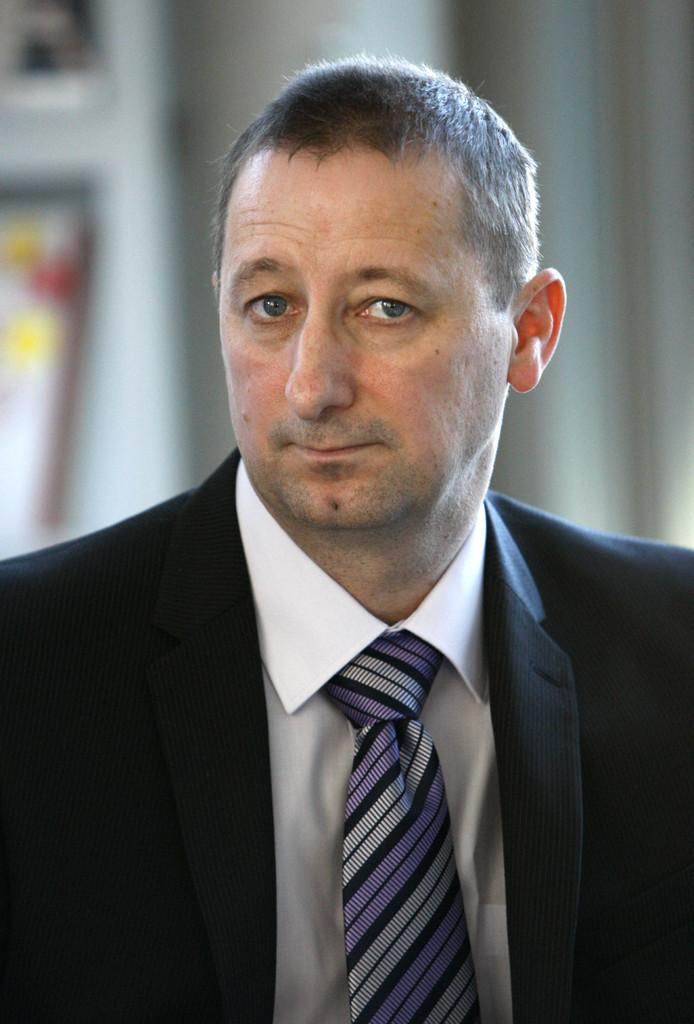What is the main subject of the image? There is a person in the image. Can you describe the person's appearance? The person is wearing clothes. What can be observed about the background of the image? The background of the image is blurred. What type of attempt is the person making in the image? There is no indication of an attempt being made in the image; it simply shows a person wearing clothes with a blurred background. How many stomachs can be seen on the person in the image? The person's stomach is not visible in the image, so it cannot be determined how many stomachs they have. 